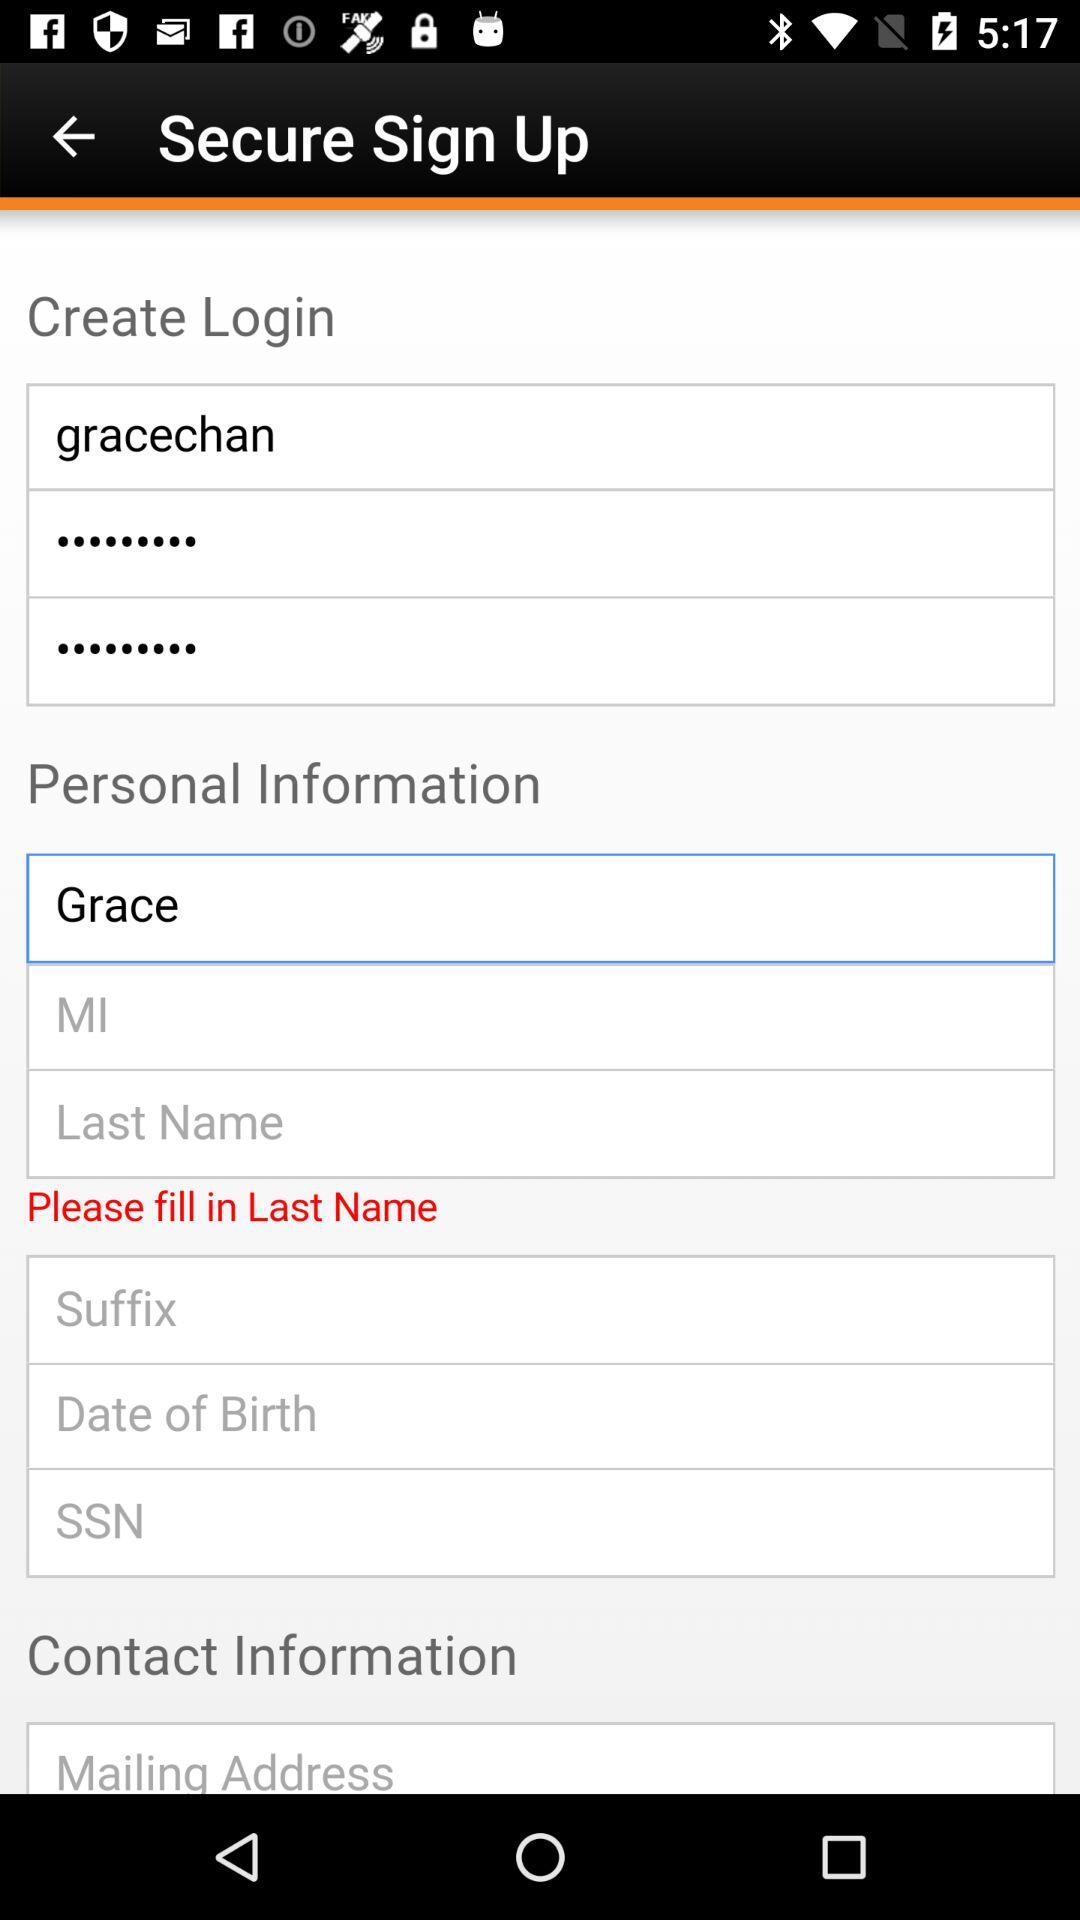What is the login ID? The login ID is "gracechan". 